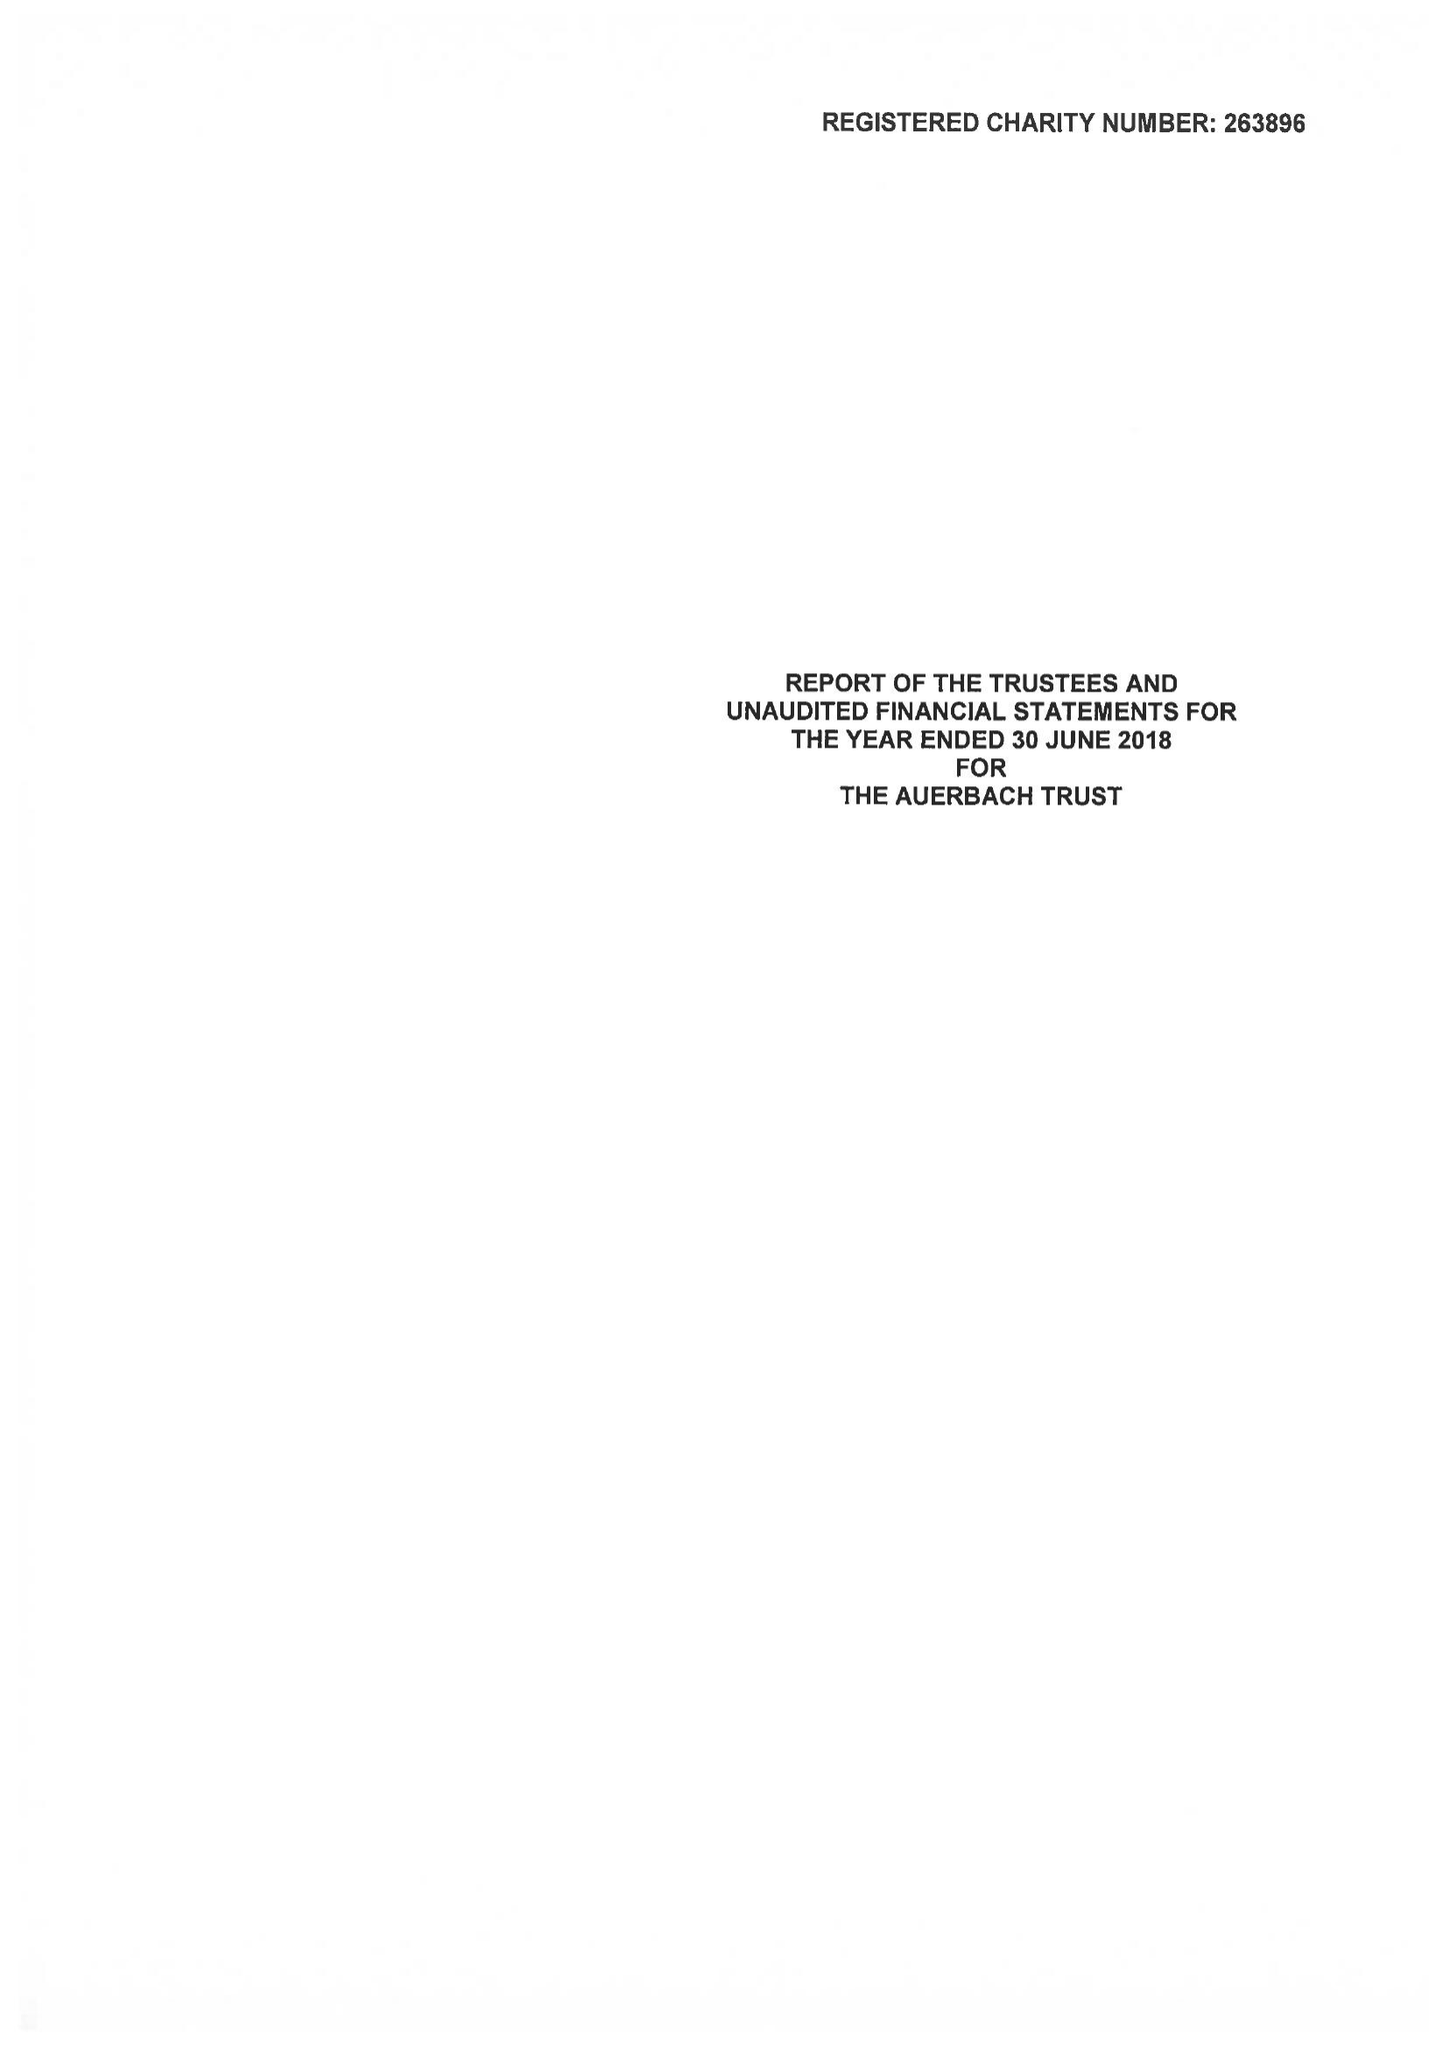What is the value for the charity_number?
Answer the question using a single word or phrase. 263896 